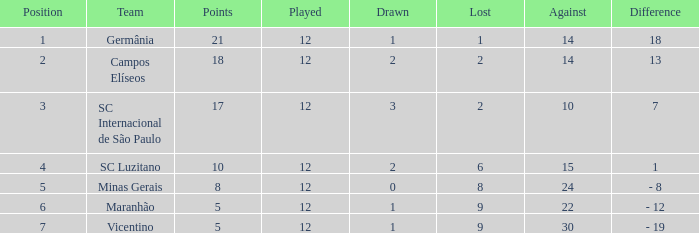What is the sum of games drawn with a participant playing more than 12 games? 0.0. 